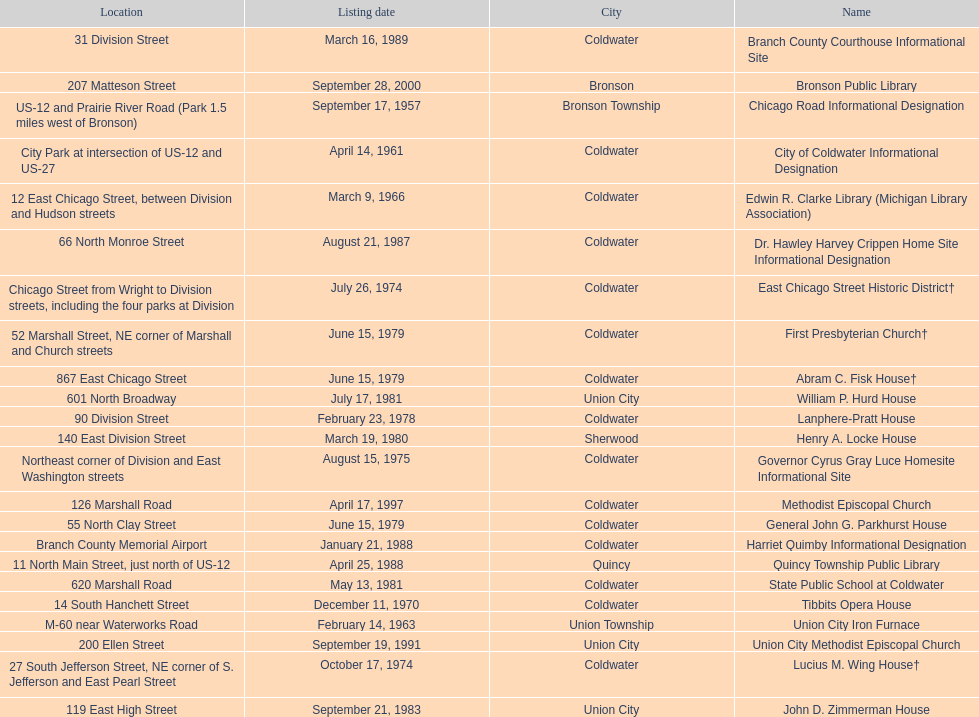How many years passed between the historic listing of public libraries in quincy and bronson? 12. 